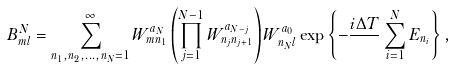<formula> <loc_0><loc_0><loc_500><loc_500>B _ { m l } ^ { N } = \sum _ { n _ { 1 } , n _ { 2 } , \dots , n _ { N } = 1 } ^ { \infty } W _ { m n _ { 1 } } ^ { a _ { N } } \left ( \prod _ { j = 1 } ^ { N - 1 } W ^ { a _ { N - j } } _ { n _ { j } n _ { j + 1 } } \right ) W _ { n _ { N } l } ^ { a _ { 0 } } \exp \left \{ - \frac { i \Delta T } { } \sum _ { i = 1 } ^ { N } E _ { n _ { i } } \right \} ,</formula> 